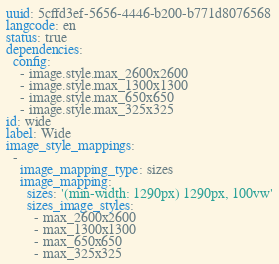<code> <loc_0><loc_0><loc_500><loc_500><_YAML_>uuid: 5cffd3ef-5656-4446-b200-b771d8076568
langcode: en
status: true
dependencies:
  config:
    - image.style.max_2600x2600
    - image.style.max_1300x1300
    - image.style.max_650x650
    - image.style.max_325x325
id: wide
label: Wide
image_style_mappings:
  -
    image_mapping_type: sizes
    image_mapping:
      sizes: '(min-width: 1290px) 1290px, 100vw'
      sizes_image_styles:
        - max_2600x2600
        - max_1300x1300
        - max_650x650
        - max_325x325</code> 